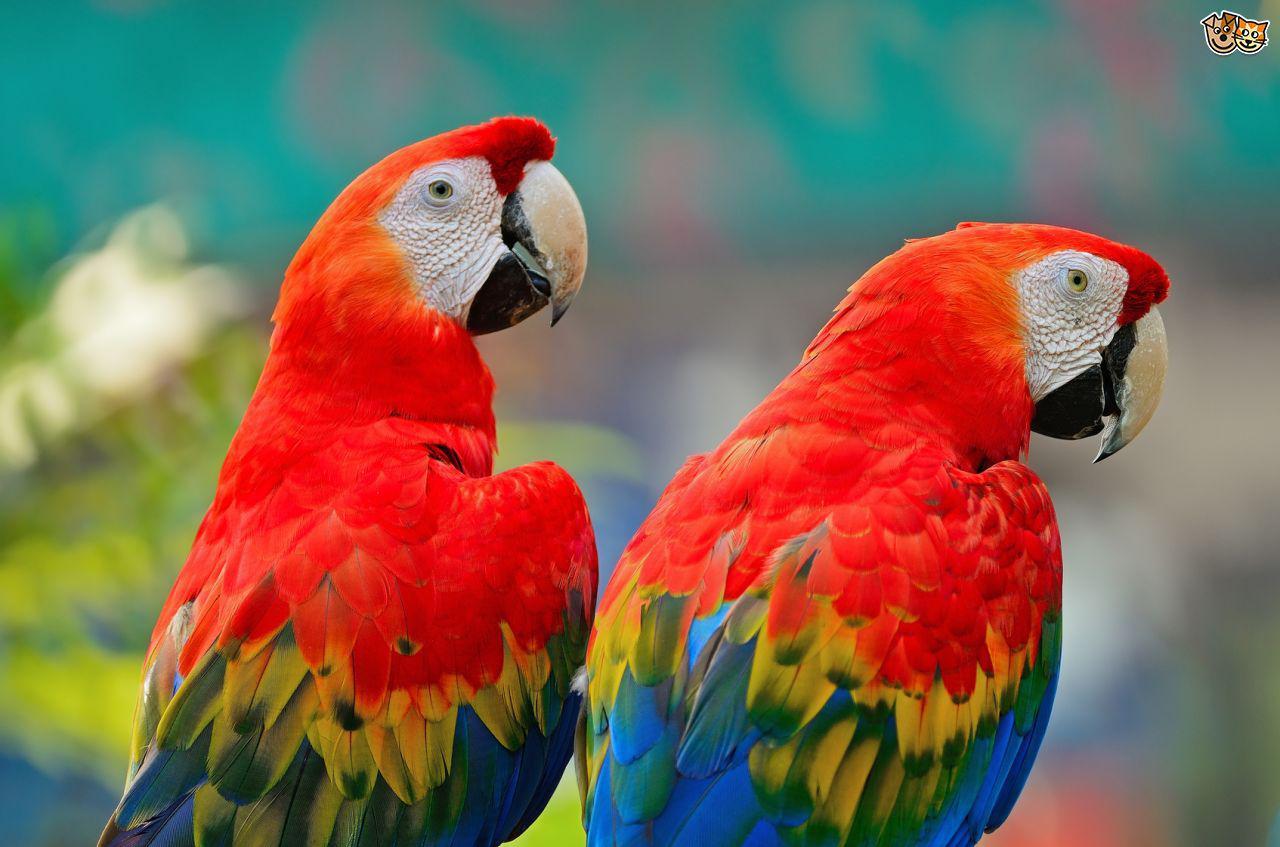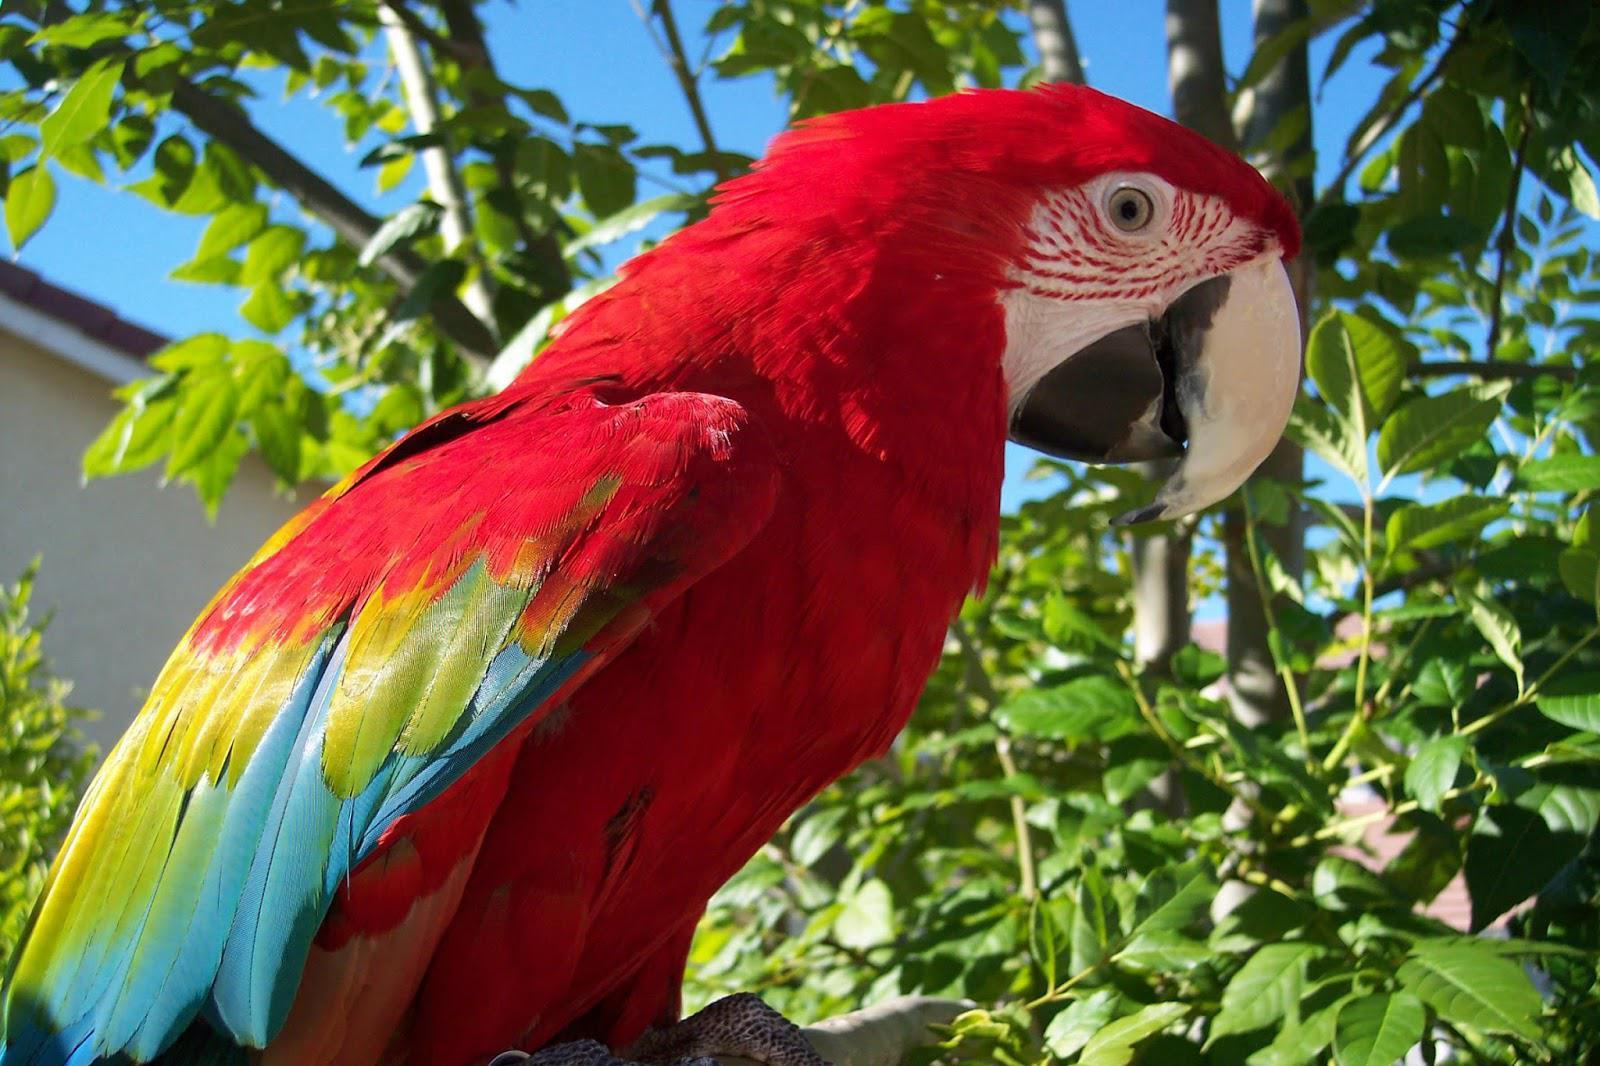The first image is the image on the left, the second image is the image on the right. For the images displayed, is the sentence "There are three parrots" factually correct? Answer yes or no. Yes. The first image is the image on the left, the second image is the image on the right. Considering the images on both sides, is "Three parrots have red feathered heads and white beaks." valid? Answer yes or no. Yes. 